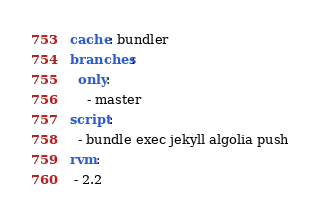Convert code to text. <code><loc_0><loc_0><loc_500><loc_500><_YAML_>cache: bundler
branches:
  only:
    - master
script:
  - bundle exec jekyll algolia push
rvm:
 - 2.2</code> 